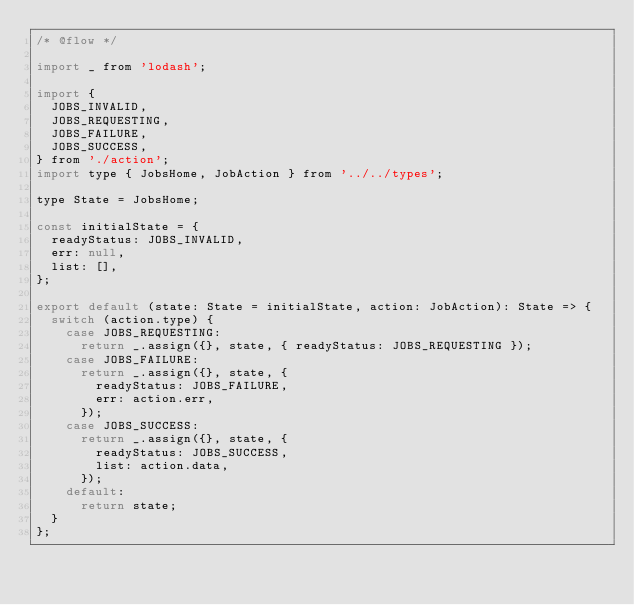<code> <loc_0><loc_0><loc_500><loc_500><_JavaScript_>/* @flow */

import _ from 'lodash';

import {
  JOBS_INVALID,
  JOBS_REQUESTING,
  JOBS_FAILURE,
  JOBS_SUCCESS,
} from './action';
import type { JobsHome, JobAction } from '../../types';

type State = JobsHome;

const initialState = {
  readyStatus: JOBS_INVALID,
  err: null,
  list: [],
};

export default (state: State = initialState, action: JobAction): State => {
  switch (action.type) {
    case JOBS_REQUESTING:
      return _.assign({}, state, { readyStatus: JOBS_REQUESTING });
    case JOBS_FAILURE:
      return _.assign({}, state, {
        readyStatus: JOBS_FAILURE,
        err: action.err,
      });
    case JOBS_SUCCESS:
      return _.assign({}, state, {
        readyStatus: JOBS_SUCCESS,
        list: action.data,
      });
    default:
      return state;
  }
};
</code> 